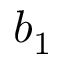<formula> <loc_0><loc_0><loc_500><loc_500>b _ { 1 }</formula> 